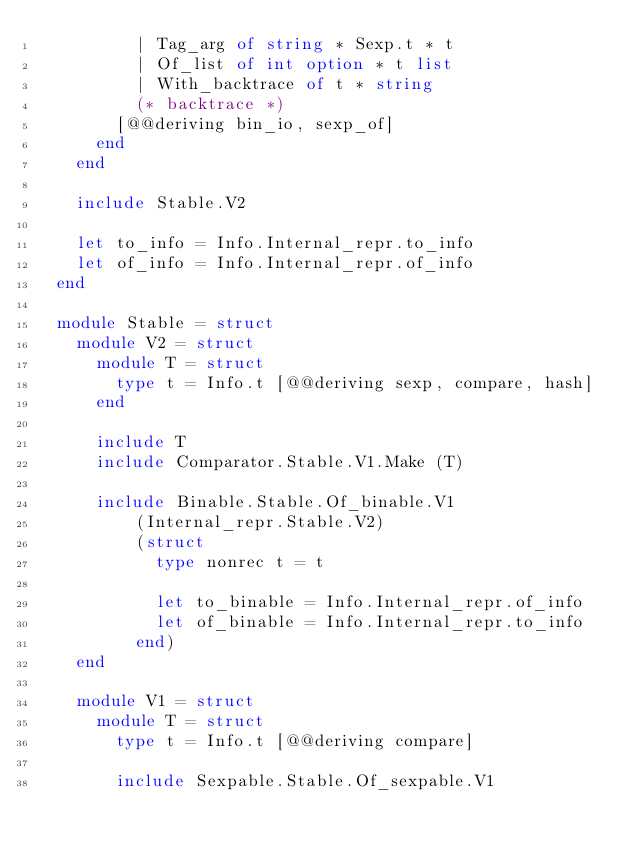Convert code to text. <code><loc_0><loc_0><loc_500><loc_500><_OCaml_>          | Tag_arg of string * Sexp.t * t
          | Of_list of int option * t list
          | With_backtrace of t * string
          (* backtrace *)
        [@@deriving bin_io, sexp_of]
      end
    end

    include Stable.V2

    let to_info = Info.Internal_repr.to_info
    let of_info = Info.Internal_repr.of_info
  end

  module Stable = struct
    module V2 = struct
      module T = struct
        type t = Info.t [@@deriving sexp, compare, hash]
      end

      include T
      include Comparator.Stable.V1.Make (T)

      include Binable.Stable.Of_binable.V1
          (Internal_repr.Stable.V2)
          (struct
            type nonrec t = t

            let to_binable = Info.Internal_repr.of_info
            let of_binable = Info.Internal_repr.to_info
          end)
    end

    module V1 = struct
      module T = struct
        type t = Info.t [@@deriving compare]

        include Sexpable.Stable.Of_sexpable.V1</code> 